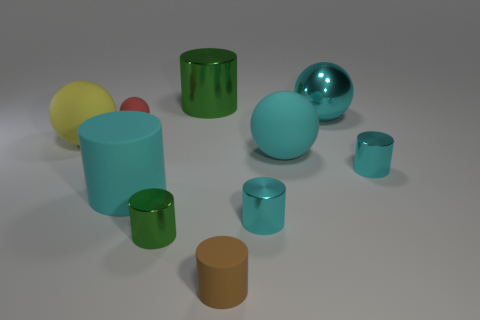Are there any other green metal things of the same shape as the big green object?
Keep it short and to the point. Yes. Is the big metal ball the same color as the small rubber sphere?
Provide a short and direct response. No. There is a large sphere that is behind the tiny matte thing that is behind the brown matte thing; what is its material?
Your answer should be very brief. Metal. How big is the yellow thing?
Make the answer very short. Large. What size is the brown cylinder that is the same material as the yellow thing?
Keep it short and to the point. Small. There is a cyan matte thing that is left of the brown cylinder; is it the same size as the big yellow rubber sphere?
Ensure brevity in your answer.  Yes. What is the shape of the cyan rubber thing that is right of the object that is in front of the small shiny thing left of the big green cylinder?
Your answer should be compact. Sphere. How many things are either big green things or objects that are in front of the cyan metallic ball?
Give a very brief answer. 9. There is a cyan metallic thing that is behind the tiny red ball; how big is it?
Provide a succinct answer. Large. What is the shape of the tiny object that is the same color as the big metal cylinder?
Your answer should be very brief. Cylinder. 